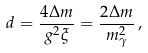<formula> <loc_0><loc_0><loc_500><loc_500>d = \frac { 4 \Delta m } { g ^ { 2 } \xi } = \frac { 2 \Delta m } { m _ { \gamma } ^ { 2 } } \, ,</formula> 